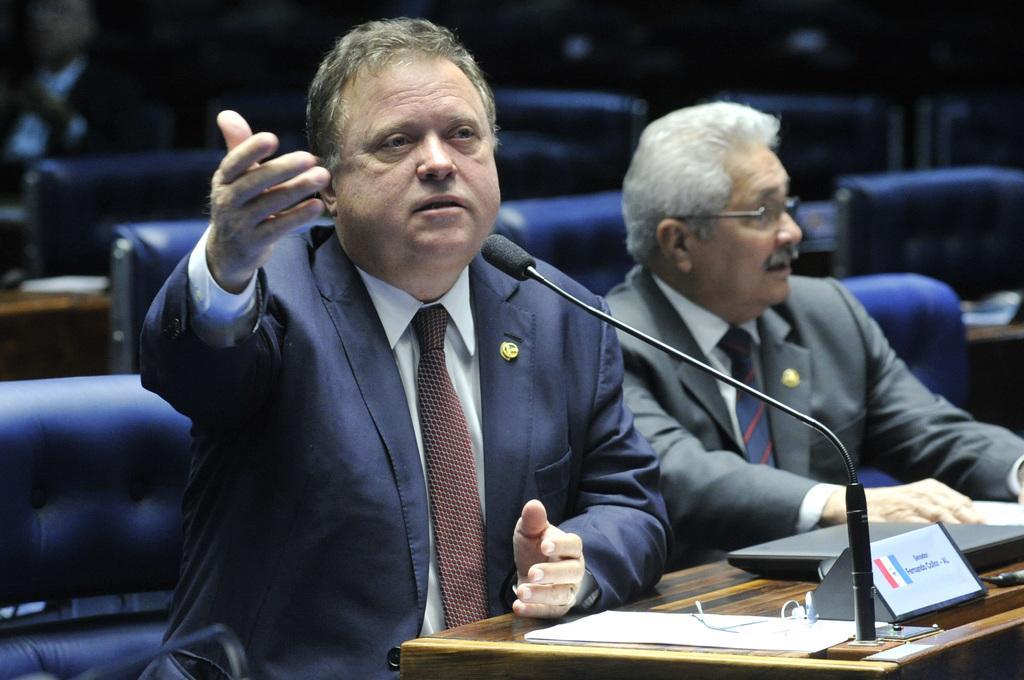In one or two sentences, can you explain what this image depicts? In this image there are two persons sitting on their chairs, in front of them there is a table. On the table there is a laptop, mic, name plate and few papers, behind them there are few empty chairs. 